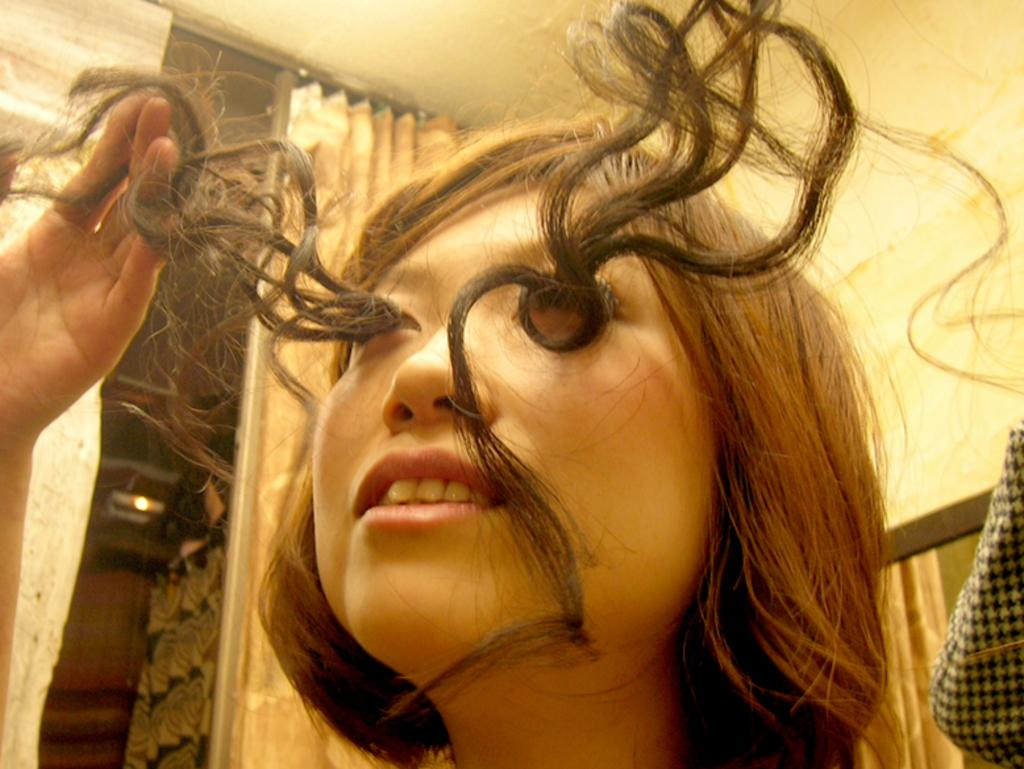Who or what is present in the image? There is a person in the image. What is the color and pattern of the cloth visible in the image? The cloth in the image is white and black. What can be seen in the background of the image? There are curtains and a wall in the background of the image. Can you see any goldfish swimming in the image? There are no goldfish present in the image. How many feet does the person in the image have? The person in the image has two feet, but this question is irrelevant as it does not pertain to any details provided in the facts. 